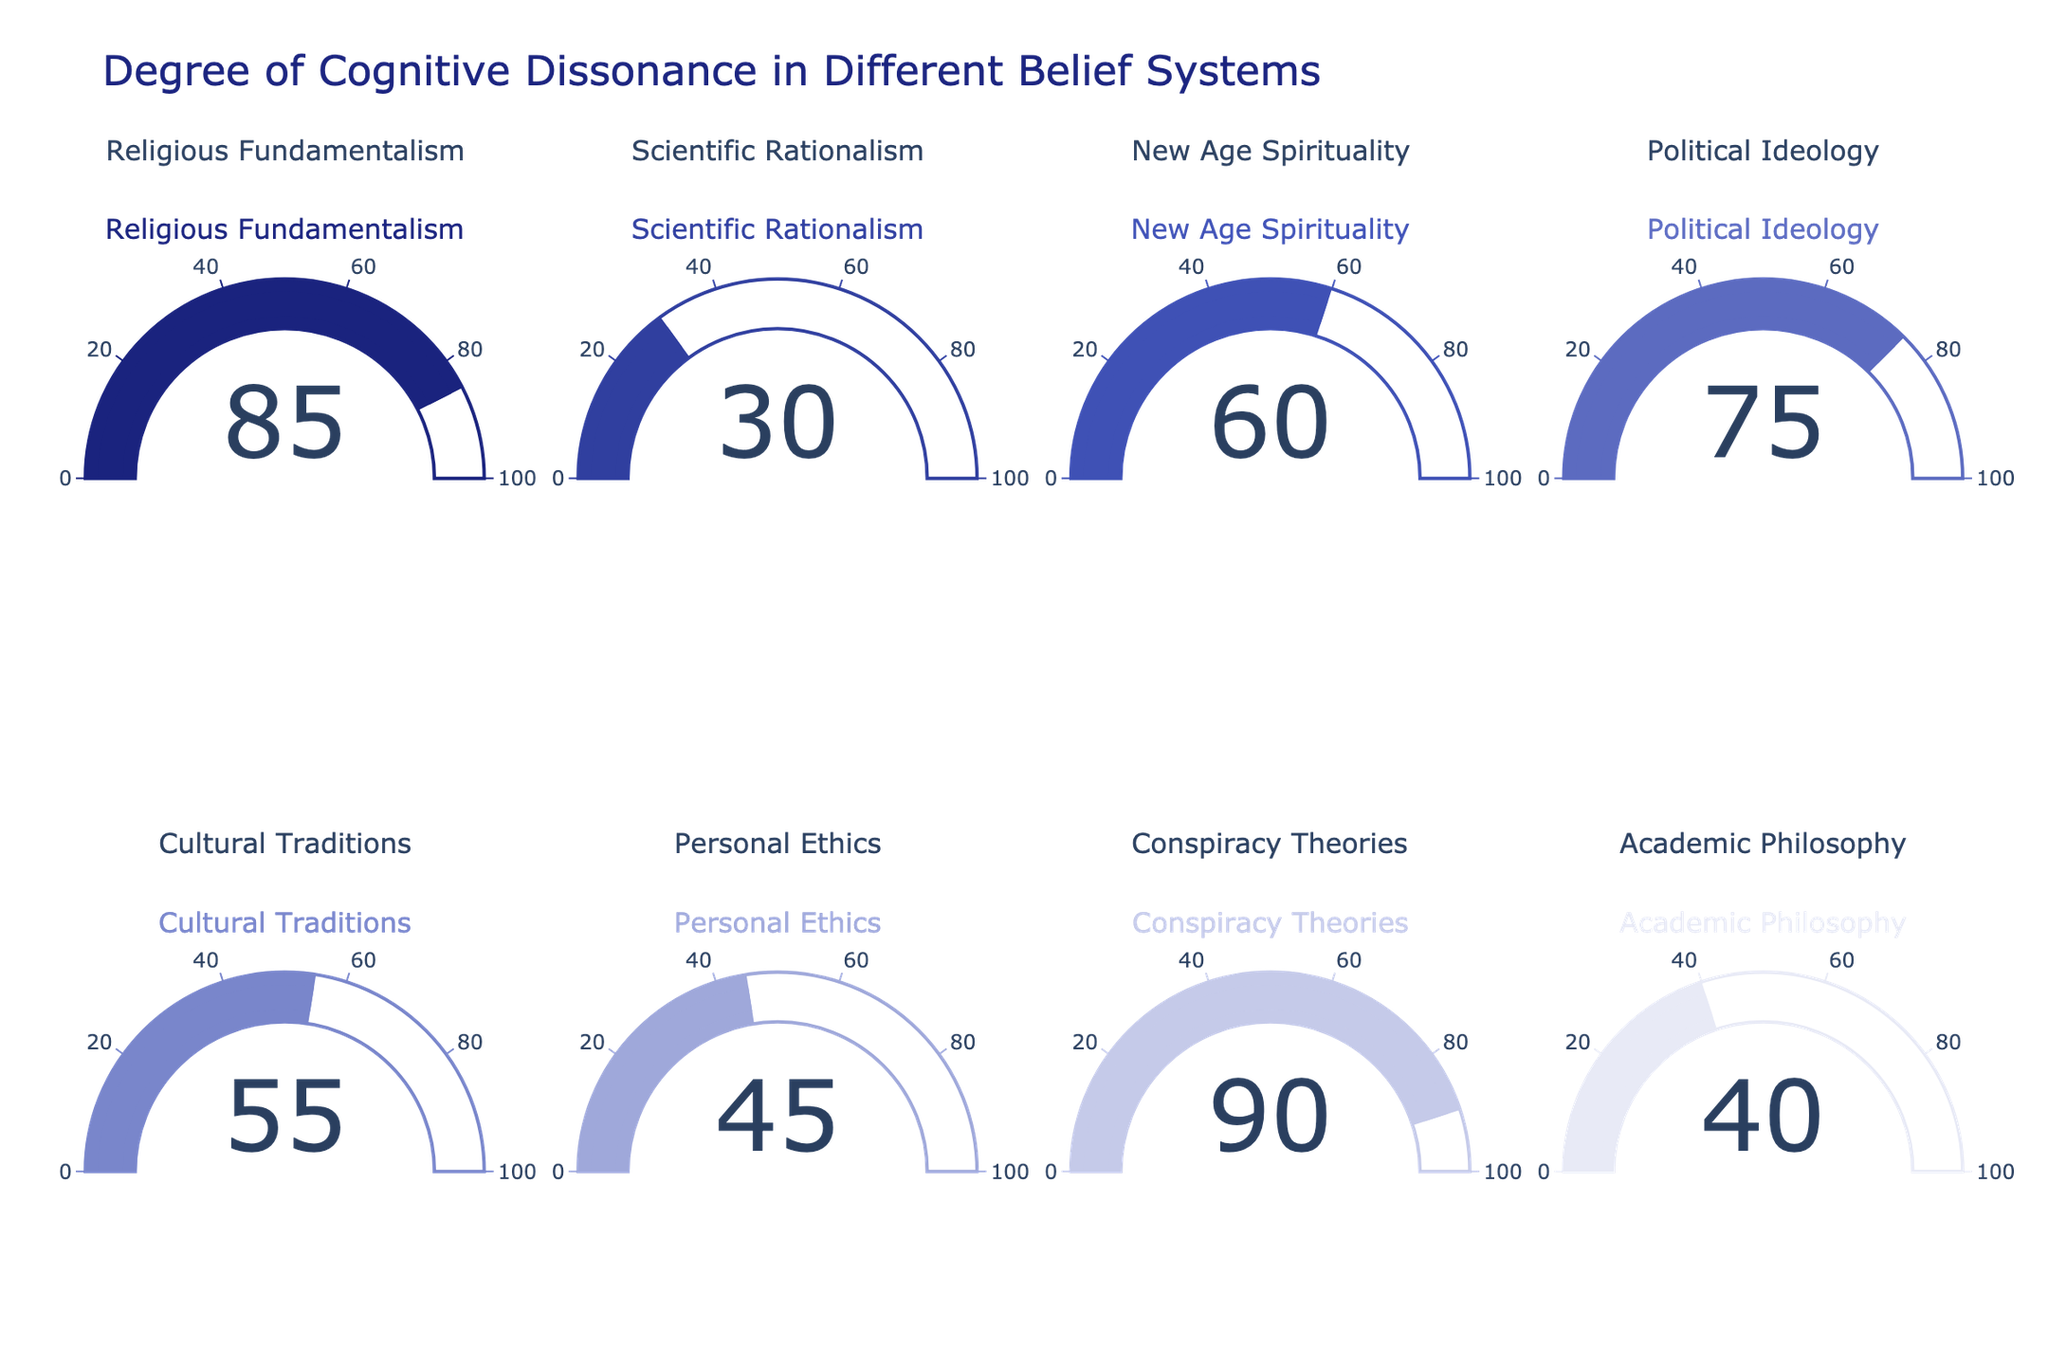What is the cognitive dissonance level associated with Scientifc Rationalism? Referring to the gauge chart labeled "Scientific Rationalism," we can see that the cognitive dissonance level is indicated by the number on the gauge.
Answer: 30 Which belief system has the highest degree of cognitive dissonance? By examining the values on the gauges, we observe that “Conspiracy Theories” has the highest cognitive dissonance level of 90, which is greater than any other belief system displayed.
Answer: Conspiracy Theories What is the difference in cognitive dissonance levels between Political Ideology and New Age Spirituality? Looking at the charts for "Political Ideology" and "New Age Spirituality," we see levels of 75 and 60, respectively. The difference can be calculated as 75 - 60.
Answer: 15 Which belief system shows a cognitive dissonance level closest to the average of all belief systems on the chart? First, calculate the average cognitive dissonance level: (85 + 30 + 60 + 75 + 55 + 45 + 90 + 40) / 8 = 60. Then, identify the belief system closest to this average, which is "New Age Spirituality" at 60.
Answer: New Age Spirituality Arrange the belief systems in ascending order of their cognitive dissonance levels. Order the values from lowest to highest: 30, 40, 45, 55, 60, 75, 85, 90, corresponding to the belief systems. The order is Scientific Rationalism, Academic Philosophy, Personal Ethics, Cultural Traditions, New Age Spirituality, Political Ideology, Religious Fundamentalism, Conspiracy Theories.
Answer: Scientific Rationalism, Academic Philosophy, Personal Ethics, Cultural Traditions, New Age Spirituality, Political Ideology, Religious Fundamentalism, Conspiracy Theories How does the cognitive dissonance level of Cultural Traditions compare to Personal Ethics? From the figure, Cultural Traditions has a cognitive dissonance level of 55, while Personal Ethics has a level of 45. Since 55 is greater than 45, Cultural Traditions has a higher cognitive dissonance level compared to Personal Ethics.
Answer: Cultural Traditions has a higher cognitive dissonance level than Personal Ethics What is the overall range of cognitive dissonance levels observed in the figure? To determine the range, subtract the lowest value (Scientific Rationalism at 30) from the highest value (Conspiracy Theories at 90). Thus, the range is 90 - 30.
Answer: 60 